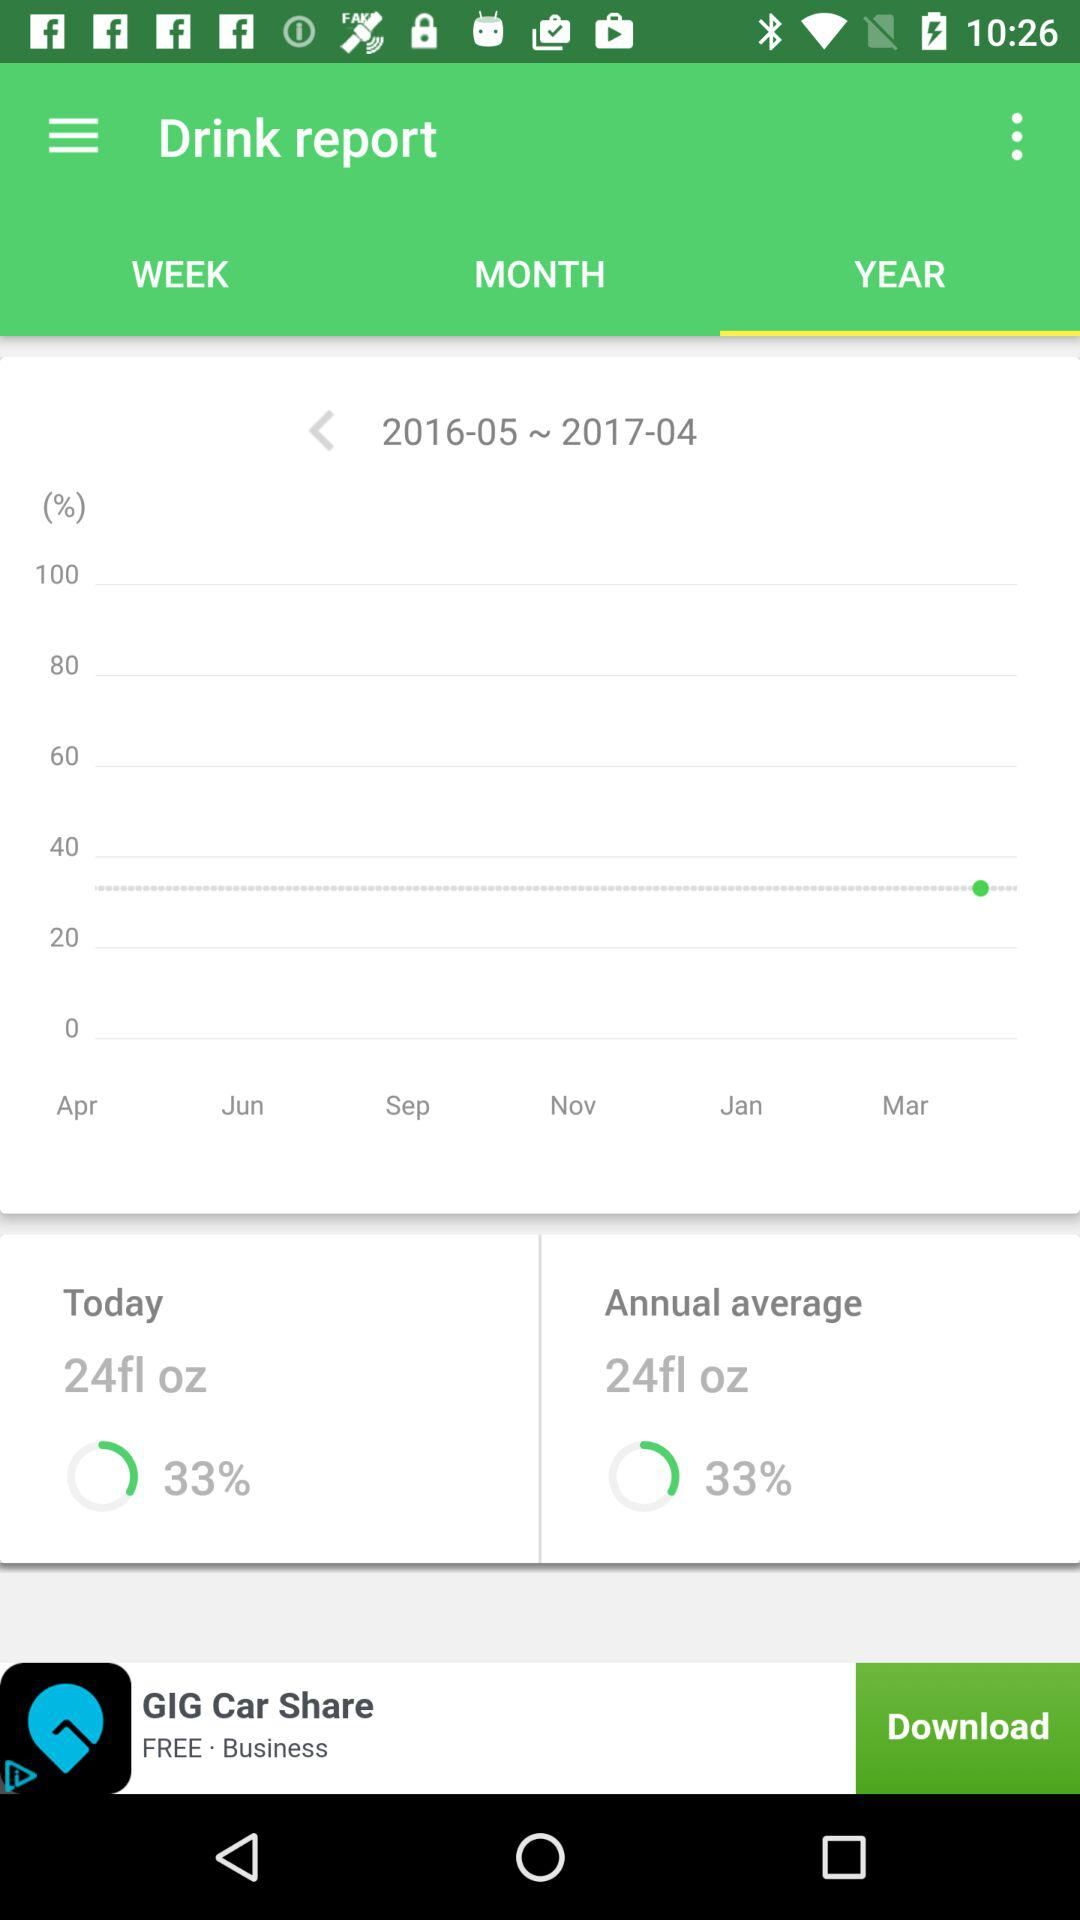What is the percentage of water consumed in the month of March?
Answer the question using a single word or phrase. 33% 